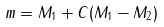Convert formula to latex. <formula><loc_0><loc_0><loc_500><loc_500>m = M _ { 1 } + C ( M _ { 1 } - M _ { 2 } )</formula> 